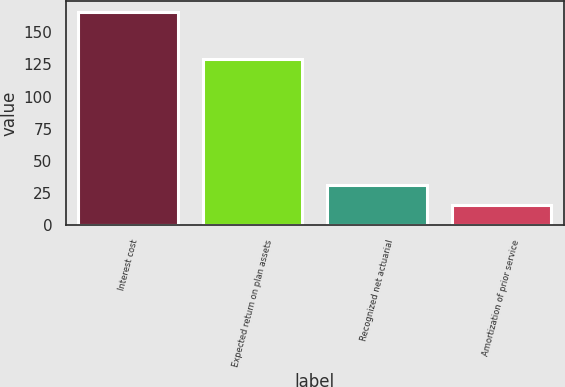Convert chart. <chart><loc_0><loc_0><loc_500><loc_500><bar_chart><fcel>Interest cost<fcel>Expected return on plan assets<fcel>Recognized net actuarial<fcel>Amortization of prior service<nl><fcel>166<fcel>129<fcel>31<fcel>16<nl></chart> 